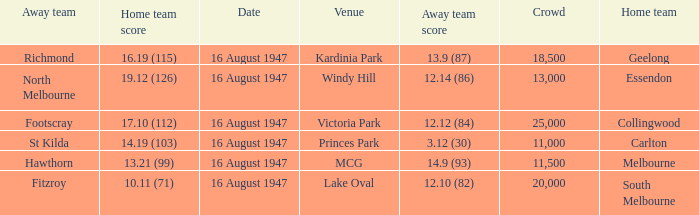What home team has had a crowd bigger than 20,000? Collingwood. 